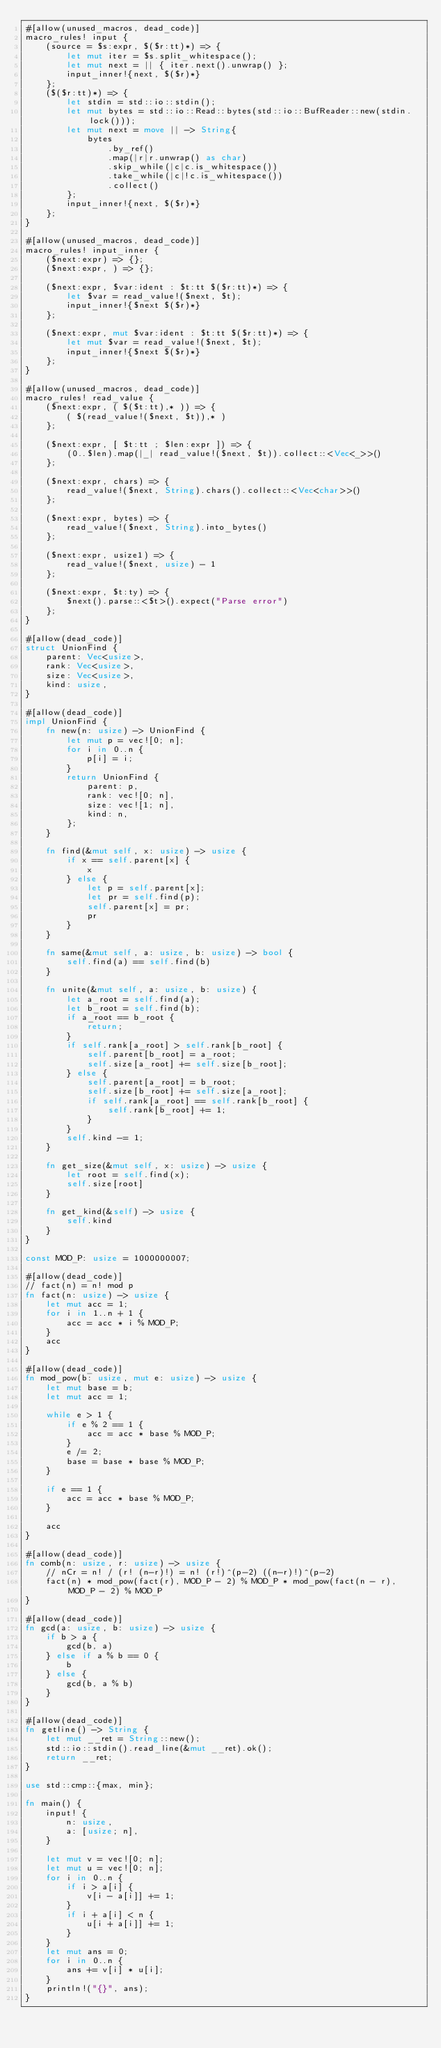<code> <loc_0><loc_0><loc_500><loc_500><_Rust_>#[allow(unused_macros, dead_code)]
macro_rules! input {
    (source = $s:expr, $($r:tt)*) => {
        let mut iter = $s.split_whitespace();
        let mut next = || { iter.next().unwrap() };
        input_inner!{next, $($r)*}
    };
    ($($r:tt)*) => {
        let stdin = std::io::stdin();
        let mut bytes = std::io::Read::bytes(std::io::BufReader::new(stdin.lock()));
        let mut next = move || -> String{
            bytes
                .by_ref()
                .map(|r|r.unwrap() as char)
                .skip_while(|c|c.is_whitespace())
                .take_while(|c|!c.is_whitespace())
                .collect()
        };
        input_inner!{next, $($r)*}
    };
}

#[allow(unused_macros, dead_code)]
macro_rules! input_inner {
    ($next:expr) => {};
    ($next:expr, ) => {};

    ($next:expr, $var:ident : $t:tt $($r:tt)*) => {
        let $var = read_value!($next, $t);
        input_inner!{$next $($r)*}
    };

    ($next:expr, mut $var:ident : $t:tt $($r:tt)*) => {
        let mut $var = read_value!($next, $t);
        input_inner!{$next $($r)*}
    };
}

#[allow(unused_macros, dead_code)]
macro_rules! read_value {
    ($next:expr, ( $($t:tt),* )) => {
        ( $(read_value!($next, $t)),* )
    };

    ($next:expr, [ $t:tt ; $len:expr ]) => {
        (0..$len).map(|_| read_value!($next, $t)).collect::<Vec<_>>()
    };

    ($next:expr, chars) => {
        read_value!($next, String).chars().collect::<Vec<char>>()
    };

    ($next:expr, bytes) => {
        read_value!($next, String).into_bytes()
    };

    ($next:expr, usize1) => {
        read_value!($next, usize) - 1
    };

    ($next:expr, $t:ty) => {
        $next().parse::<$t>().expect("Parse error")
    };
}

#[allow(dead_code)]
struct UnionFind {
    parent: Vec<usize>,
    rank: Vec<usize>,
    size: Vec<usize>,
    kind: usize,
}

#[allow(dead_code)]
impl UnionFind {
    fn new(n: usize) -> UnionFind {
        let mut p = vec![0; n];
        for i in 0..n {
            p[i] = i;
        }
        return UnionFind {
            parent: p,
            rank: vec![0; n],
            size: vec![1; n],
            kind: n,
        };
    }

    fn find(&mut self, x: usize) -> usize {
        if x == self.parent[x] {
            x
        } else {
            let p = self.parent[x];
            let pr = self.find(p);
            self.parent[x] = pr;
            pr
        }
    }

    fn same(&mut self, a: usize, b: usize) -> bool {
        self.find(a) == self.find(b)
    }

    fn unite(&mut self, a: usize, b: usize) {
        let a_root = self.find(a);
        let b_root = self.find(b);
        if a_root == b_root {
            return;
        }
        if self.rank[a_root] > self.rank[b_root] {
            self.parent[b_root] = a_root;
            self.size[a_root] += self.size[b_root];
        } else {
            self.parent[a_root] = b_root;
            self.size[b_root] += self.size[a_root];
            if self.rank[a_root] == self.rank[b_root] {
                self.rank[b_root] += 1;
            }
        }
        self.kind -= 1;
    }

    fn get_size(&mut self, x: usize) -> usize {
        let root = self.find(x);
        self.size[root]
    }

    fn get_kind(&self) -> usize {
        self.kind
    }
}

const MOD_P: usize = 1000000007;

#[allow(dead_code)]
// fact(n) = n! mod p
fn fact(n: usize) -> usize {
    let mut acc = 1;
    for i in 1..n + 1 {
        acc = acc * i % MOD_P;
    }
    acc
}

#[allow(dead_code)]
fn mod_pow(b: usize, mut e: usize) -> usize {
    let mut base = b;
    let mut acc = 1;

    while e > 1 {
        if e % 2 == 1 {
            acc = acc * base % MOD_P;
        }
        e /= 2;
        base = base * base % MOD_P;
    }

    if e == 1 {
        acc = acc * base % MOD_P;
    }

    acc
}

#[allow(dead_code)]
fn comb(n: usize, r: usize) -> usize {
    // nCr = n! / (r! (n-r)!) = n! (r!)^(p-2) ((n-r)!)^(p-2)
    fact(n) * mod_pow(fact(r), MOD_P - 2) % MOD_P * mod_pow(fact(n - r), MOD_P - 2) % MOD_P
}

#[allow(dead_code)]
fn gcd(a: usize, b: usize) -> usize {
    if b > a {
        gcd(b, a)
    } else if a % b == 0 {
        b
    } else {
        gcd(b, a % b)
    }
}

#[allow(dead_code)]
fn getline() -> String {
    let mut __ret = String::new();
    std::io::stdin().read_line(&mut __ret).ok();
    return __ret;
}

use std::cmp::{max, min};

fn main() {
    input! {
        n: usize,
        a: [usize; n],
    }

    let mut v = vec![0; n];
    let mut u = vec![0; n];
    for i in 0..n {
        if i > a[i] {
            v[i - a[i]] += 1;
        }
        if i + a[i] < n {
            u[i + a[i]] += 1;
        }
    }
    let mut ans = 0;
    for i in 0..n {
        ans += v[i] * u[i];
    }
    println!("{}", ans);
}
</code> 